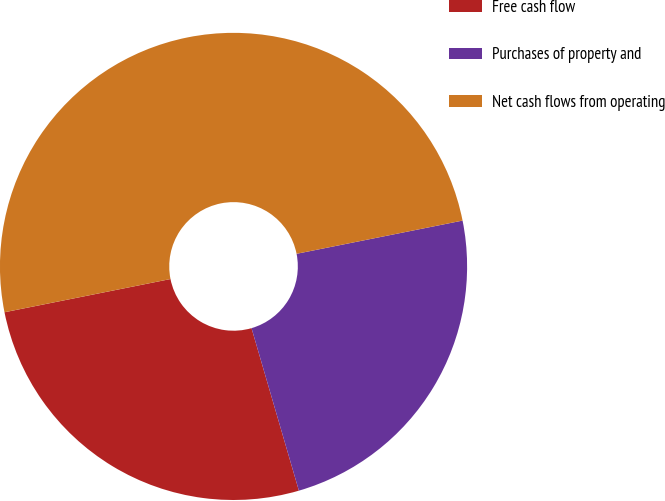<chart> <loc_0><loc_0><loc_500><loc_500><pie_chart><fcel>Free cash flow<fcel>Purchases of property and<fcel>Net cash flows from operating<nl><fcel>26.37%<fcel>23.63%<fcel>50.0%<nl></chart> 